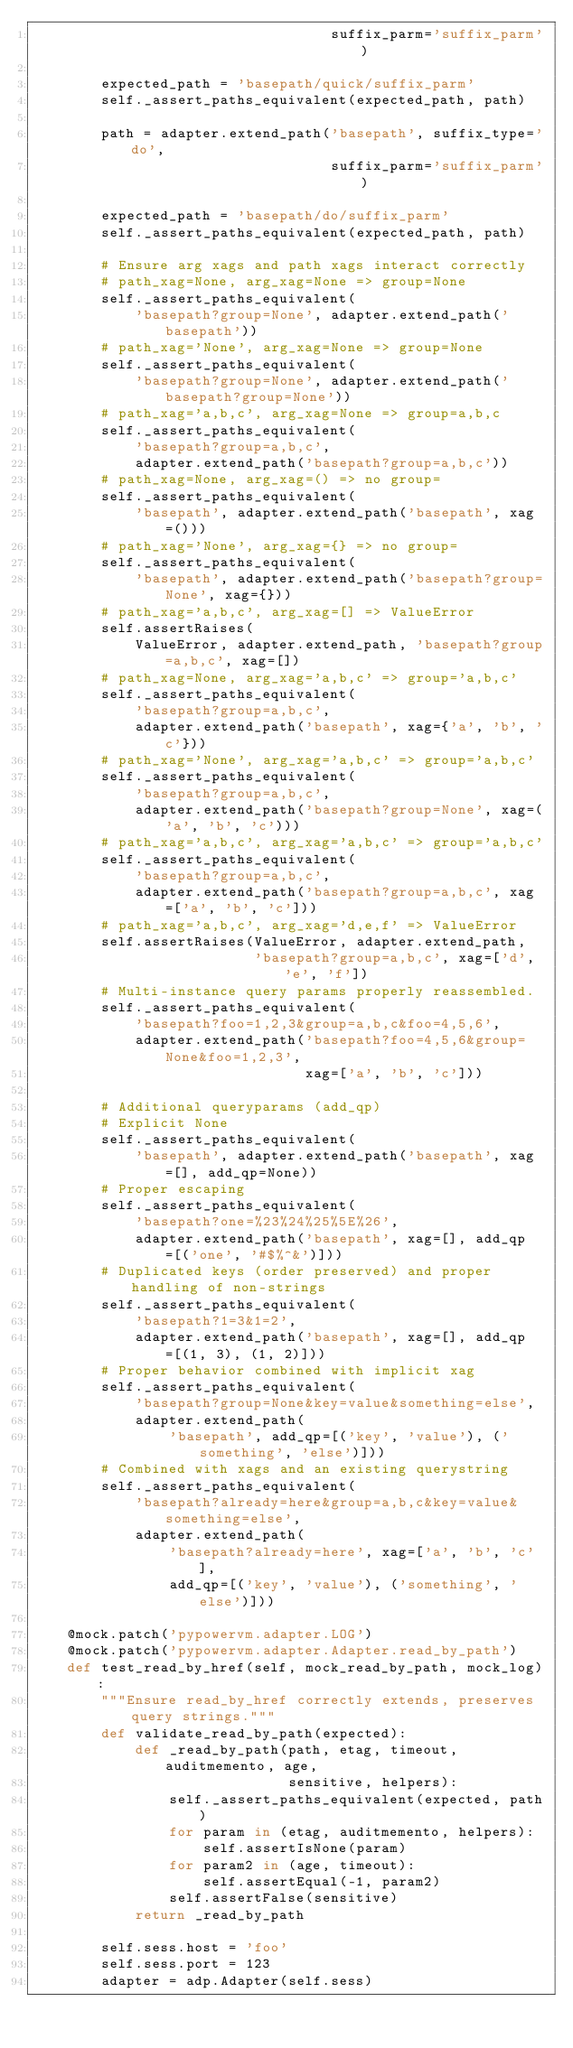<code> <loc_0><loc_0><loc_500><loc_500><_Python_>                                   suffix_parm='suffix_parm')

        expected_path = 'basepath/quick/suffix_parm'
        self._assert_paths_equivalent(expected_path, path)

        path = adapter.extend_path('basepath', suffix_type='do',
                                   suffix_parm='suffix_parm')

        expected_path = 'basepath/do/suffix_parm'
        self._assert_paths_equivalent(expected_path, path)

        # Ensure arg xags and path xags interact correctly
        # path_xag=None, arg_xag=None => group=None
        self._assert_paths_equivalent(
            'basepath?group=None', adapter.extend_path('basepath'))
        # path_xag='None', arg_xag=None => group=None
        self._assert_paths_equivalent(
            'basepath?group=None', adapter.extend_path('basepath?group=None'))
        # path_xag='a,b,c', arg_xag=None => group=a,b,c
        self._assert_paths_equivalent(
            'basepath?group=a,b,c',
            adapter.extend_path('basepath?group=a,b,c'))
        # path_xag=None, arg_xag=() => no group=
        self._assert_paths_equivalent(
            'basepath', adapter.extend_path('basepath', xag=()))
        # path_xag='None', arg_xag={} => no group=
        self._assert_paths_equivalent(
            'basepath', adapter.extend_path('basepath?group=None', xag={}))
        # path_xag='a,b,c', arg_xag=[] => ValueError
        self.assertRaises(
            ValueError, adapter.extend_path, 'basepath?group=a,b,c', xag=[])
        # path_xag=None, arg_xag='a,b,c' => group='a,b,c'
        self._assert_paths_equivalent(
            'basepath?group=a,b,c',
            adapter.extend_path('basepath', xag={'a', 'b', 'c'}))
        # path_xag='None', arg_xag='a,b,c' => group='a,b,c'
        self._assert_paths_equivalent(
            'basepath?group=a,b,c',
            adapter.extend_path('basepath?group=None', xag=('a', 'b', 'c')))
        # path_xag='a,b,c', arg_xag='a,b,c' => group='a,b,c'
        self._assert_paths_equivalent(
            'basepath?group=a,b,c',
            adapter.extend_path('basepath?group=a,b,c', xag=['a', 'b', 'c']))
        # path_xag='a,b,c', arg_xag='d,e,f' => ValueError
        self.assertRaises(ValueError, adapter.extend_path,
                          'basepath?group=a,b,c', xag=['d', 'e', 'f'])
        # Multi-instance query params properly reassembled.
        self._assert_paths_equivalent(
            'basepath?foo=1,2,3&group=a,b,c&foo=4,5,6',
            adapter.extend_path('basepath?foo=4,5,6&group=None&foo=1,2,3',
                                xag=['a', 'b', 'c']))

        # Additional queryparams (add_qp)
        # Explicit None
        self._assert_paths_equivalent(
            'basepath', adapter.extend_path('basepath', xag=[], add_qp=None))
        # Proper escaping
        self._assert_paths_equivalent(
            'basepath?one=%23%24%25%5E%26',
            adapter.extend_path('basepath', xag=[], add_qp=[('one', '#$%^&')]))
        # Duplicated keys (order preserved) and proper handling of non-strings
        self._assert_paths_equivalent(
            'basepath?1=3&1=2',
            adapter.extend_path('basepath', xag=[], add_qp=[(1, 3), (1, 2)]))
        # Proper behavior combined with implicit xag
        self._assert_paths_equivalent(
            'basepath?group=None&key=value&something=else',
            adapter.extend_path(
                'basepath', add_qp=[('key', 'value'), ('something', 'else')]))
        # Combined with xags and an existing querystring
        self._assert_paths_equivalent(
            'basepath?already=here&group=a,b,c&key=value&something=else',
            adapter.extend_path(
                'basepath?already=here', xag=['a', 'b', 'c'],
                add_qp=[('key', 'value'), ('something', 'else')]))

    @mock.patch('pypowervm.adapter.LOG')
    @mock.patch('pypowervm.adapter.Adapter.read_by_path')
    def test_read_by_href(self, mock_read_by_path, mock_log):
        """Ensure read_by_href correctly extends, preserves query strings."""
        def validate_read_by_path(expected):
            def _read_by_path(path, etag, timeout, auditmemento, age,
                              sensitive, helpers):
                self._assert_paths_equivalent(expected, path)
                for param in (etag, auditmemento, helpers):
                    self.assertIsNone(param)
                for param2 in (age, timeout):
                    self.assertEqual(-1, param2)
                self.assertFalse(sensitive)
            return _read_by_path

        self.sess.host = 'foo'
        self.sess.port = 123
        adapter = adp.Adapter(self.sess)</code> 